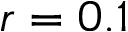Convert formula to latex. <formula><loc_0><loc_0><loc_500><loc_500>r = 0 . 1</formula> 